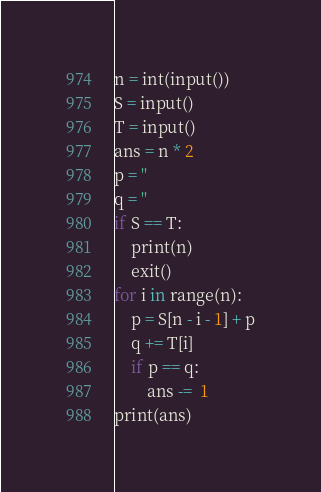Convert code to text. <code><loc_0><loc_0><loc_500><loc_500><_Python_>n = int(input())
S = input()
T = input()
ans = n * 2
p = ''
q = ''
if S == T:
    print(n)
    exit()
for i in range(n):
    p = S[n - i - 1] + p
    q += T[i]
    if p == q:
        ans -=  1
print(ans)
</code> 